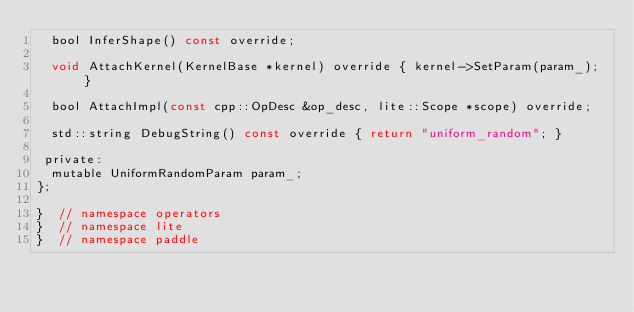<code> <loc_0><loc_0><loc_500><loc_500><_C_>  bool InferShape() const override;

  void AttachKernel(KernelBase *kernel) override { kernel->SetParam(param_); }

  bool AttachImpl(const cpp::OpDesc &op_desc, lite::Scope *scope) override;

  std::string DebugString() const override { return "uniform_random"; }

 private:
  mutable UniformRandomParam param_;
};

}  // namespace operators
}  // namespace lite
}  // namespace paddle
</code> 